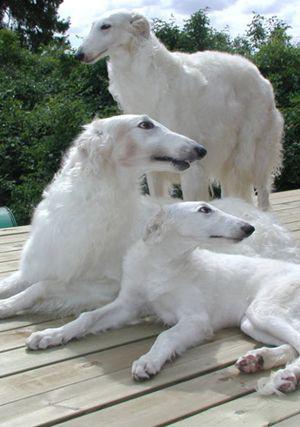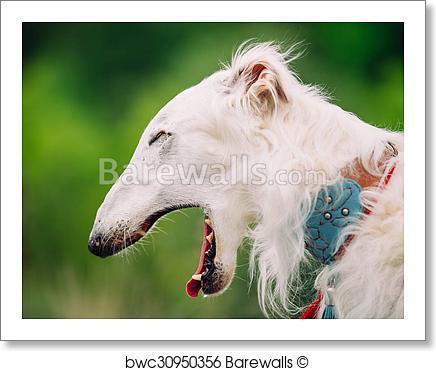The first image is the image on the left, the second image is the image on the right. For the images displayed, is the sentence "The single white dog in the image on the left is standing in a grassy area." factually correct? Answer yes or no. No. The first image is the image on the left, the second image is the image on the right. Analyze the images presented: Is the assertion "The left image contains at least three times as many hounds as the right image." valid? Answer yes or no. Yes. 